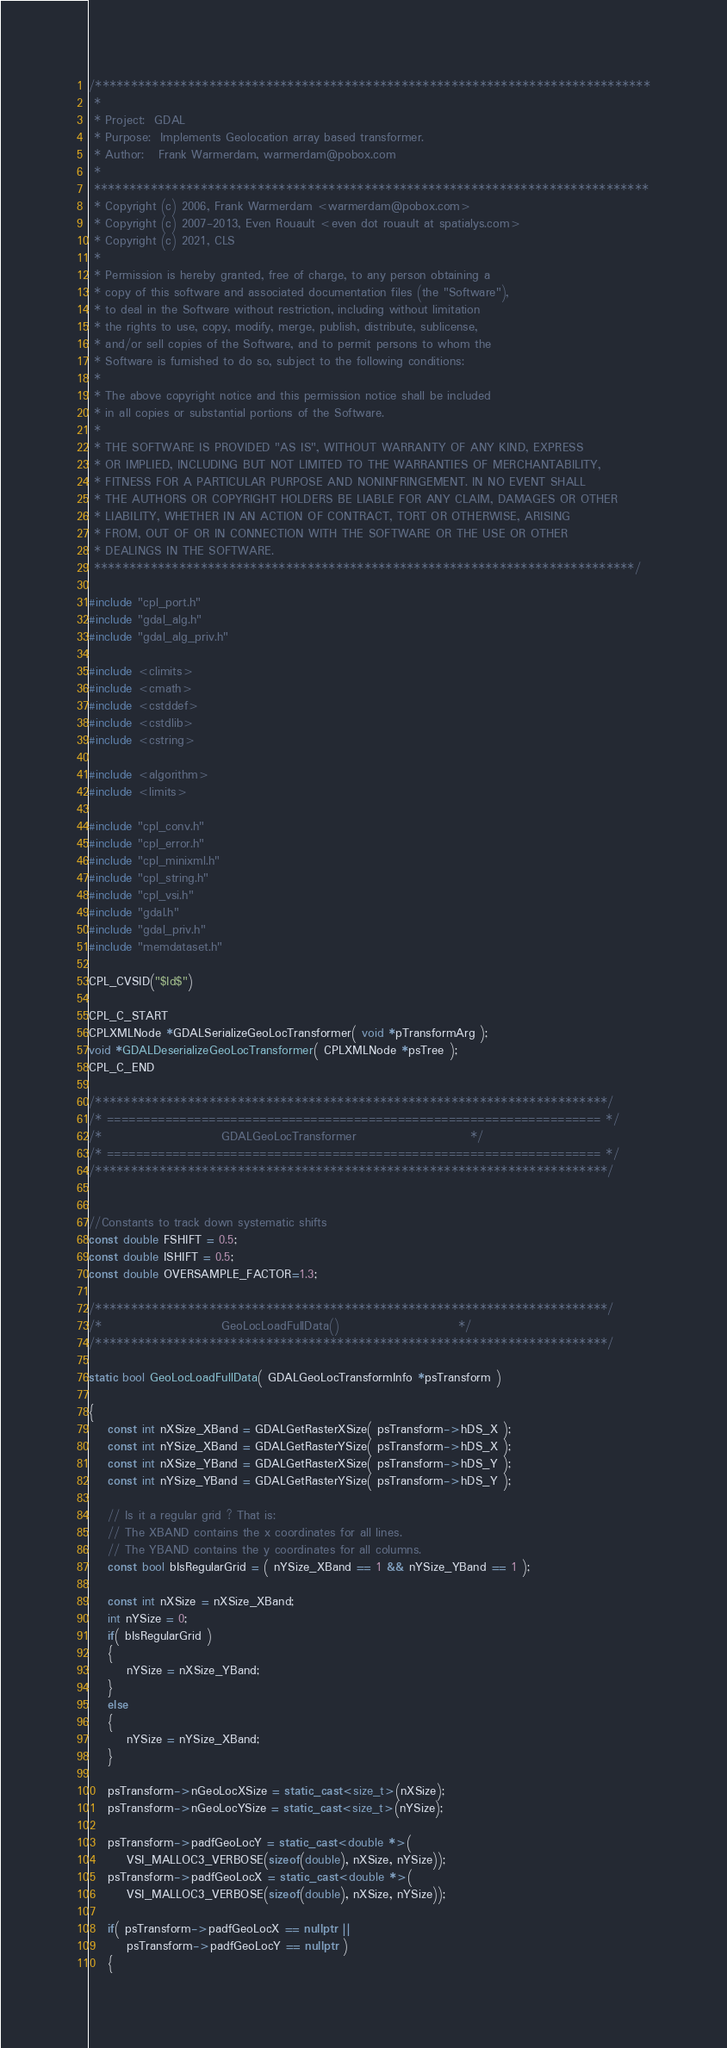<code> <loc_0><loc_0><loc_500><loc_500><_C++_>/******************************************************************************
 *
 * Project:  GDAL
 * Purpose:  Implements Geolocation array based transformer.
 * Author:   Frank Warmerdam, warmerdam@pobox.com
 *
 ******************************************************************************
 * Copyright (c) 2006, Frank Warmerdam <warmerdam@pobox.com>
 * Copyright (c) 2007-2013, Even Rouault <even dot rouault at spatialys.com>
 * Copyright (c) 2021, CLS
 *
 * Permission is hereby granted, free of charge, to any person obtaining a
 * copy of this software and associated documentation files (the "Software"),
 * to deal in the Software without restriction, including without limitation
 * the rights to use, copy, modify, merge, publish, distribute, sublicense,
 * and/or sell copies of the Software, and to permit persons to whom the
 * Software is furnished to do so, subject to the following conditions:
 *
 * The above copyright notice and this permission notice shall be included
 * in all copies or substantial portions of the Software.
 *
 * THE SOFTWARE IS PROVIDED "AS IS", WITHOUT WARRANTY OF ANY KIND, EXPRESS
 * OR IMPLIED, INCLUDING BUT NOT LIMITED TO THE WARRANTIES OF MERCHANTABILITY,
 * FITNESS FOR A PARTICULAR PURPOSE AND NONINFRINGEMENT. IN NO EVENT SHALL
 * THE AUTHORS OR COPYRIGHT HOLDERS BE LIABLE FOR ANY CLAIM, DAMAGES OR OTHER
 * LIABILITY, WHETHER IN AN ACTION OF CONTRACT, TORT OR OTHERWISE, ARISING
 * FROM, OUT OF OR IN CONNECTION WITH THE SOFTWARE OR THE USE OR OTHER
 * DEALINGS IN THE SOFTWARE.
 ****************************************************************************/

#include "cpl_port.h"
#include "gdal_alg.h"
#include "gdal_alg_priv.h"

#include <climits>
#include <cmath>
#include <cstddef>
#include <cstdlib>
#include <cstring>

#include <algorithm>
#include <limits>

#include "cpl_conv.h"
#include "cpl_error.h"
#include "cpl_minixml.h"
#include "cpl_string.h"
#include "cpl_vsi.h"
#include "gdal.h"
#include "gdal_priv.h"
#include "memdataset.h"

CPL_CVSID("$Id$")

CPL_C_START
CPLXMLNode *GDALSerializeGeoLocTransformer( void *pTransformArg );
void *GDALDeserializeGeoLocTransformer( CPLXMLNode *psTree );
CPL_C_END

/************************************************************************/
/* ==================================================================== */
/*                         GDALGeoLocTransformer                        */
/* ==================================================================== */
/************************************************************************/


//Constants to track down systematic shifts
const double FSHIFT = 0.5;
const double ISHIFT = 0.5;
const double OVERSAMPLE_FACTOR=1.3;

/************************************************************************/
/*                         GeoLocLoadFullData()                         */
/************************************************************************/

static bool GeoLocLoadFullData( GDALGeoLocTransformInfo *psTransform )

{
    const int nXSize_XBand = GDALGetRasterXSize( psTransform->hDS_X );
    const int nYSize_XBand = GDALGetRasterYSize( psTransform->hDS_X );
    const int nXSize_YBand = GDALGetRasterXSize( psTransform->hDS_Y );
    const int nYSize_YBand = GDALGetRasterYSize( psTransform->hDS_Y );

    // Is it a regular grid ? That is:
    // The XBAND contains the x coordinates for all lines.
    // The YBAND contains the y coordinates for all columns.
    const bool bIsRegularGrid = ( nYSize_XBand == 1 && nYSize_YBand == 1 );

    const int nXSize = nXSize_XBand;
    int nYSize = 0;
    if( bIsRegularGrid )
    {
        nYSize = nXSize_YBand;
    }
    else
    {
        nYSize = nYSize_XBand;
    }

    psTransform->nGeoLocXSize = static_cast<size_t>(nXSize);
    psTransform->nGeoLocYSize = static_cast<size_t>(nYSize);

    psTransform->padfGeoLocY = static_cast<double *>(
        VSI_MALLOC3_VERBOSE(sizeof(double), nXSize, nYSize));
    psTransform->padfGeoLocX = static_cast<double *>(
        VSI_MALLOC3_VERBOSE(sizeof(double), nXSize, nYSize));

    if( psTransform->padfGeoLocX == nullptr ||
        psTransform->padfGeoLocY == nullptr )
    {</code> 